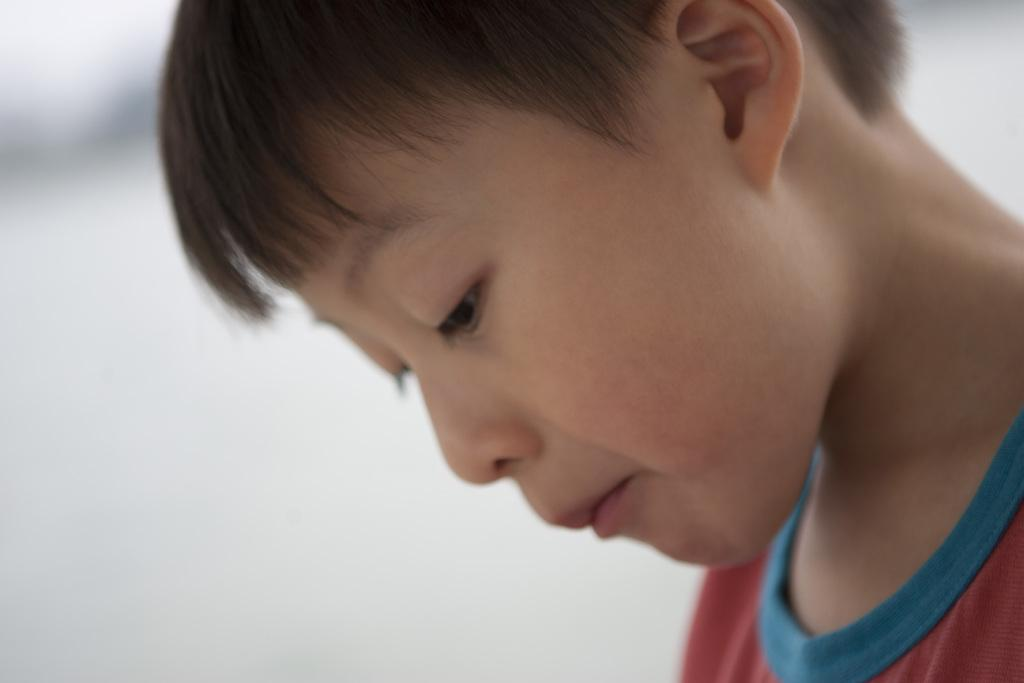Who is the main subject in the image? There is a boy in the image. What is the boy wearing? The boy is wearing a red T-shirt. How many eyes, ears, and other facial features does the boy have? The boy has two eyes, a nose, a mouth, and an ear. What color is the background of the image? The background of the image is white in color. What type of whip is the boy holding in the image? There is no whip present in the image. Is the boy using a gun in the image? There is no gun present in the image. 